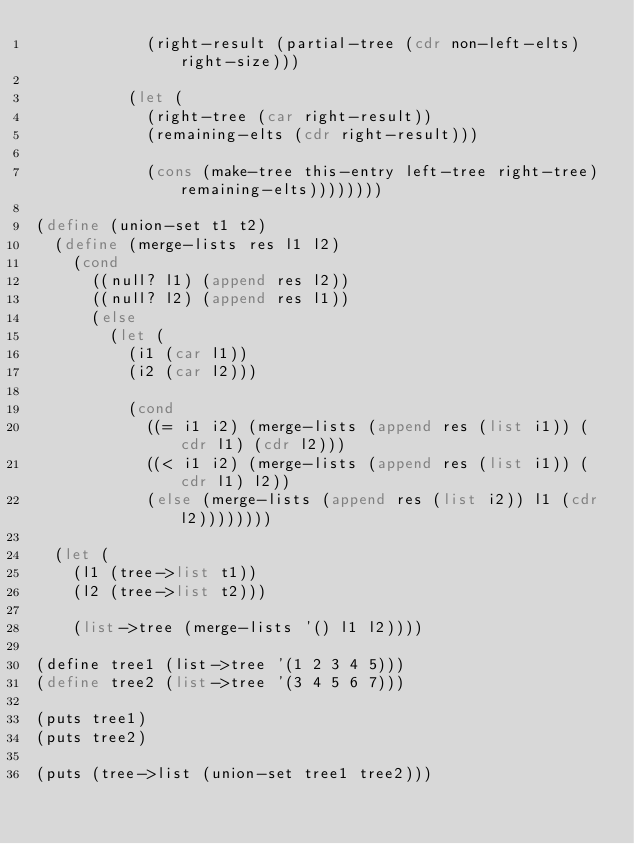<code> <loc_0><loc_0><loc_500><loc_500><_Scheme_>            (right-result (partial-tree (cdr non-left-elts) right-size)))

          (let (
            (right-tree (car right-result))
            (remaining-elts (cdr right-result)))

            (cons (make-tree this-entry left-tree right-tree) remaining-elts))))))))

(define (union-set t1 t2)
  (define (merge-lists res l1 l2)
    (cond
      ((null? l1) (append res l2))
      ((null? l2) (append res l1))
      (else
        (let (
          (i1 (car l1))
          (i2 (car l2)))

          (cond
            ((= i1 i2) (merge-lists (append res (list i1)) (cdr l1) (cdr l2)))
            ((< i1 i2) (merge-lists (append res (list i1)) (cdr l1) l2))
            (else (merge-lists (append res (list i2)) l1 (cdr l2))))))))

  (let (
    (l1 (tree->list t1))
    (l2 (tree->list t2)))

    (list->tree (merge-lists '() l1 l2))))

(define tree1 (list->tree '(1 2 3 4 5)))
(define tree2 (list->tree '(3 4 5 6 7)))

(puts tree1)
(puts tree2)

(puts (tree->list (union-set tree1 tree2)))

</code> 